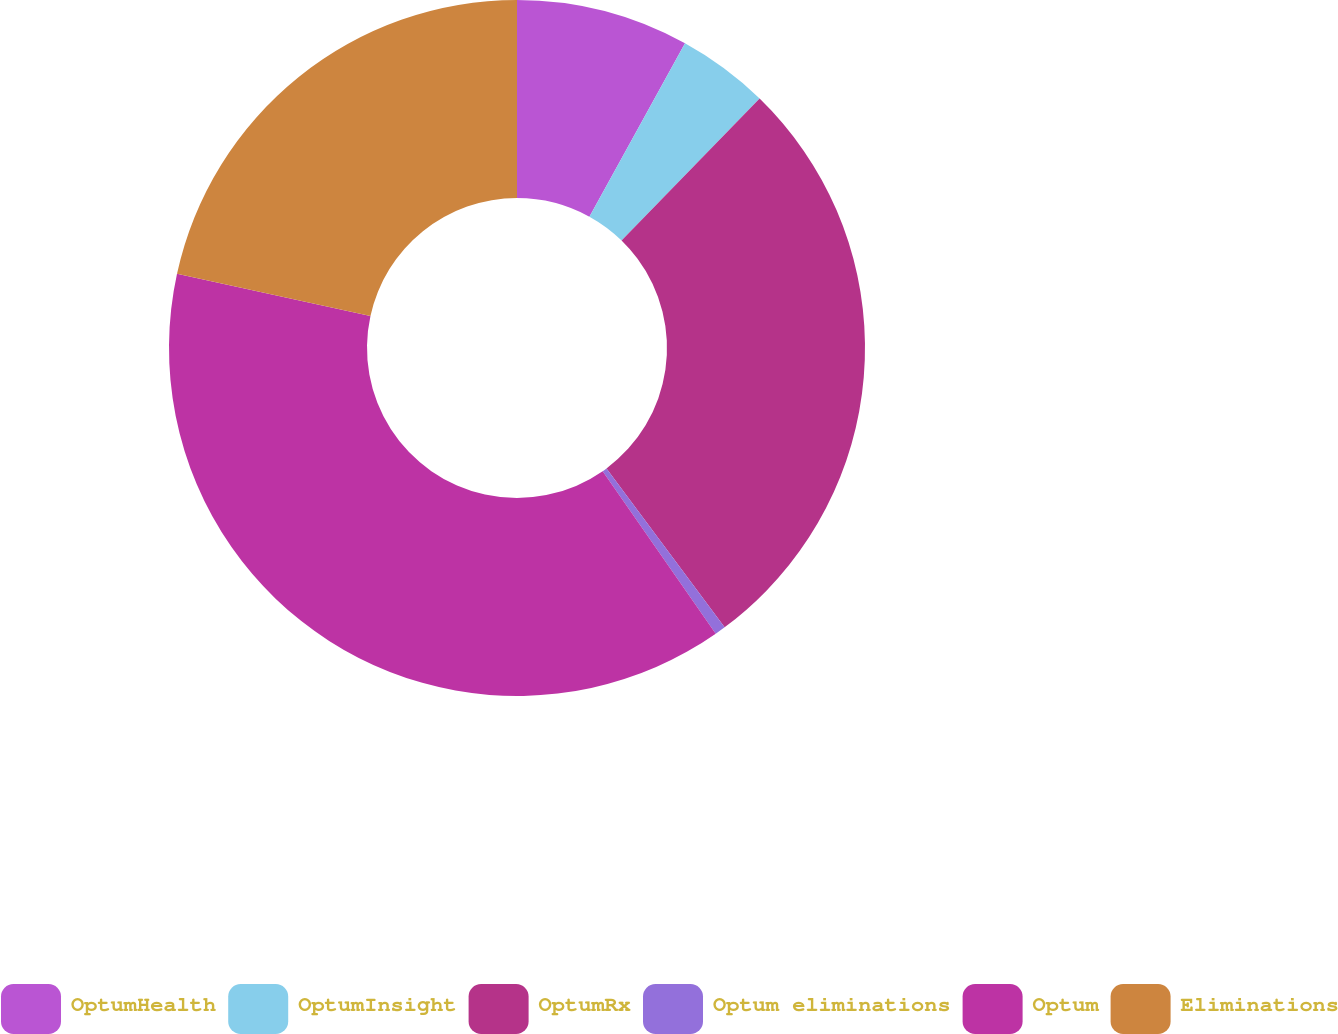<chart> <loc_0><loc_0><loc_500><loc_500><pie_chart><fcel>OptumHealth<fcel>OptumInsight<fcel>OptumRx<fcel>Optum eliminations<fcel>Optum<fcel>Eliminations<nl><fcel>8.02%<fcel>4.26%<fcel>27.55%<fcel>0.5%<fcel>38.1%<fcel>21.58%<nl></chart> 